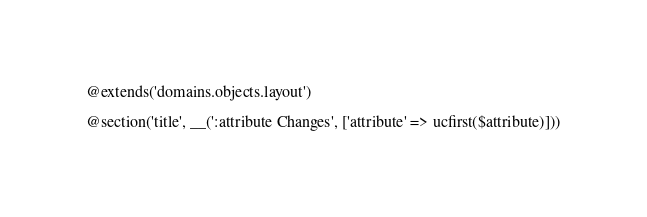Convert code to text. <code><loc_0><loc_0><loc_500><loc_500><_PHP_>@extends('domains.objects.layout')

@section('title', __(':attribute Changes', ['attribute' => ucfirst($attribute)]))
</code> 